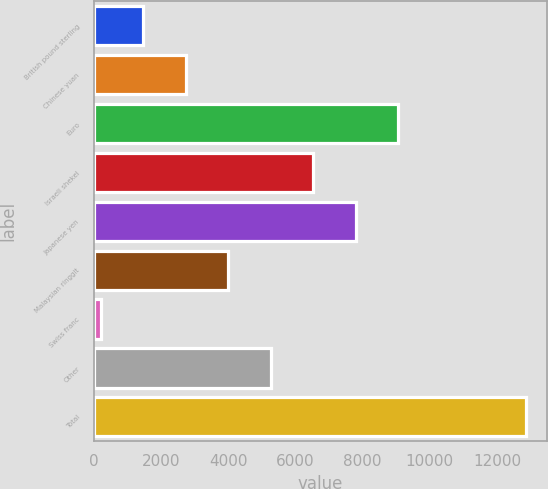<chart> <loc_0><loc_0><loc_500><loc_500><bar_chart><fcel>British pound sterling<fcel>Chinese yuan<fcel>Euro<fcel>Israeli shekel<fcel>Japanese yen<fcel>Malaysian ringgit<fcel>Swiss franc<fcel>Other<fcel>Total<nl><fcel>1473.4<fcel>2737.8<fcel>9059.8<fcel>6531<fcel>7795.4<fcel>4002.2<fcel>209<fcel>5266.6<fcel>12853<nl></chart> 